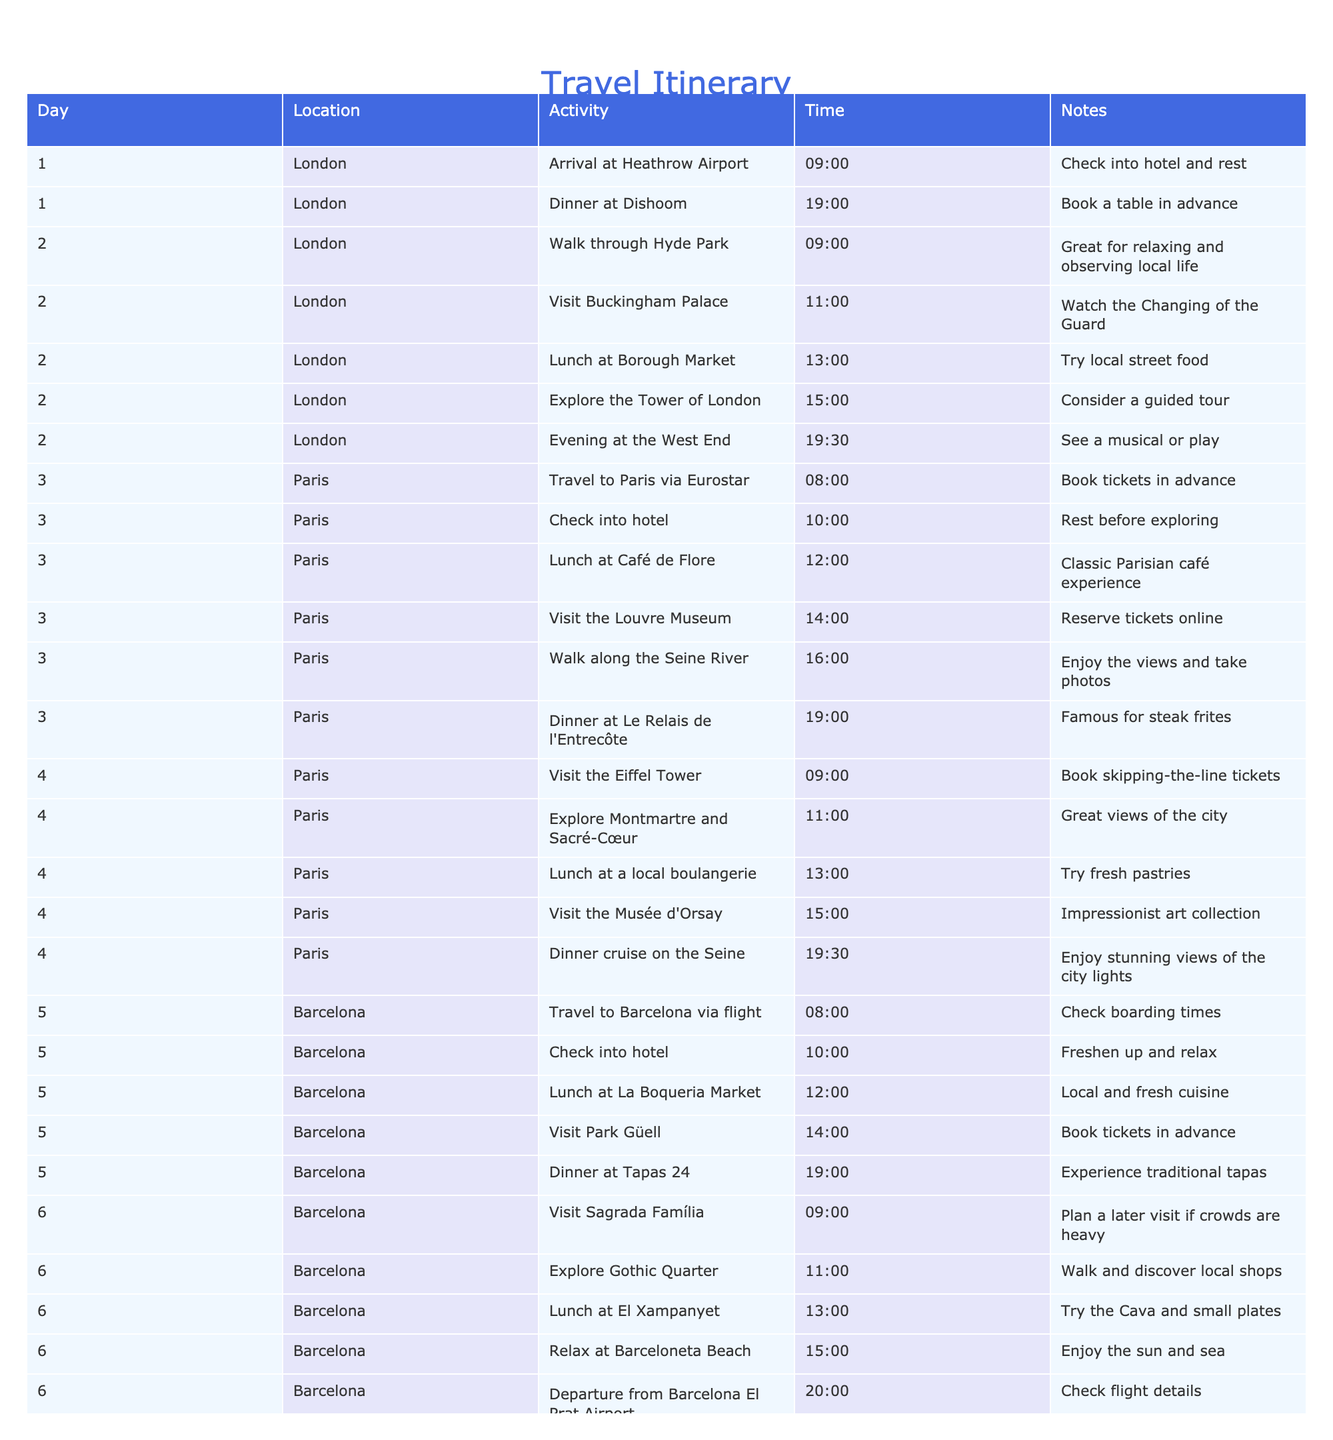What is the first activity planned in London? The first activity in the table for London is "Arrival at Heathrow Airport" scheduled for 09:00 on Day 1.
Answer: Arrival at Heathrow Airport What time is dinner planned on the first day? The dinner on the first day is scheduled for 19:00 at Dishoom.
Answer: 19:00 Which two cities are included in the itinerary after London? After London, the itinerary includes Paris and Barcelona.
Answer: Paris and Barcelona Is there a planned visit to the Louvre Museum in Paris? Yes, there is a planned visit to the Louvre Museum on Day 3 at 14:00.
Answer: Yes What is the total number of activities scheduled in Barcelona? In Barcelona, there are four activities planned including lunch, visiting Park Güell, visiting Sagrada Família, and exploring the Gothic Quarter.
Answer: Four activities How many meals are scheduled per day on average throughout the trip? There are a total of 12 meals (2 for each of the 6 days), so the average is 12 meals / 6 days = 2 meals per day.
Answer: 2 meals At what time do travelers depart from Barcelona on the last day? Travelers are scheduled to depart from Barcelona El Prat Airport at 20:00 on Day 6.
Answer: 20:00 On which day is the dinner cruise on the Seine scheduled? The dinner cruise on the Seine is scheduled for Day 4 at 19:30.
Answer: Day 4 What is the time difference between the lunch at Café de Flore and the visit to the Louvre Museum on the same day? Lunch at Café de Flore is at 12:00 and the visit to the Louvre Museum is at 14:00, making the time difference 2 hours.
Answer: 2 hours 